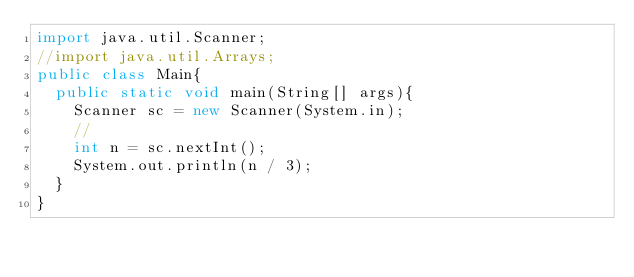Convert code to text. <code><loc_0><loc_0><loc_500><loc_500><_Java_>import java.util.Scanner;
//import java.util.Arrays;
public class Main{
	public static void main(String[] args){
		Scanner sc = new Scanner(System.in);
		//
		int n = sc.nextInt();
		System.out.println(n / 3);
	}
}
</code> 